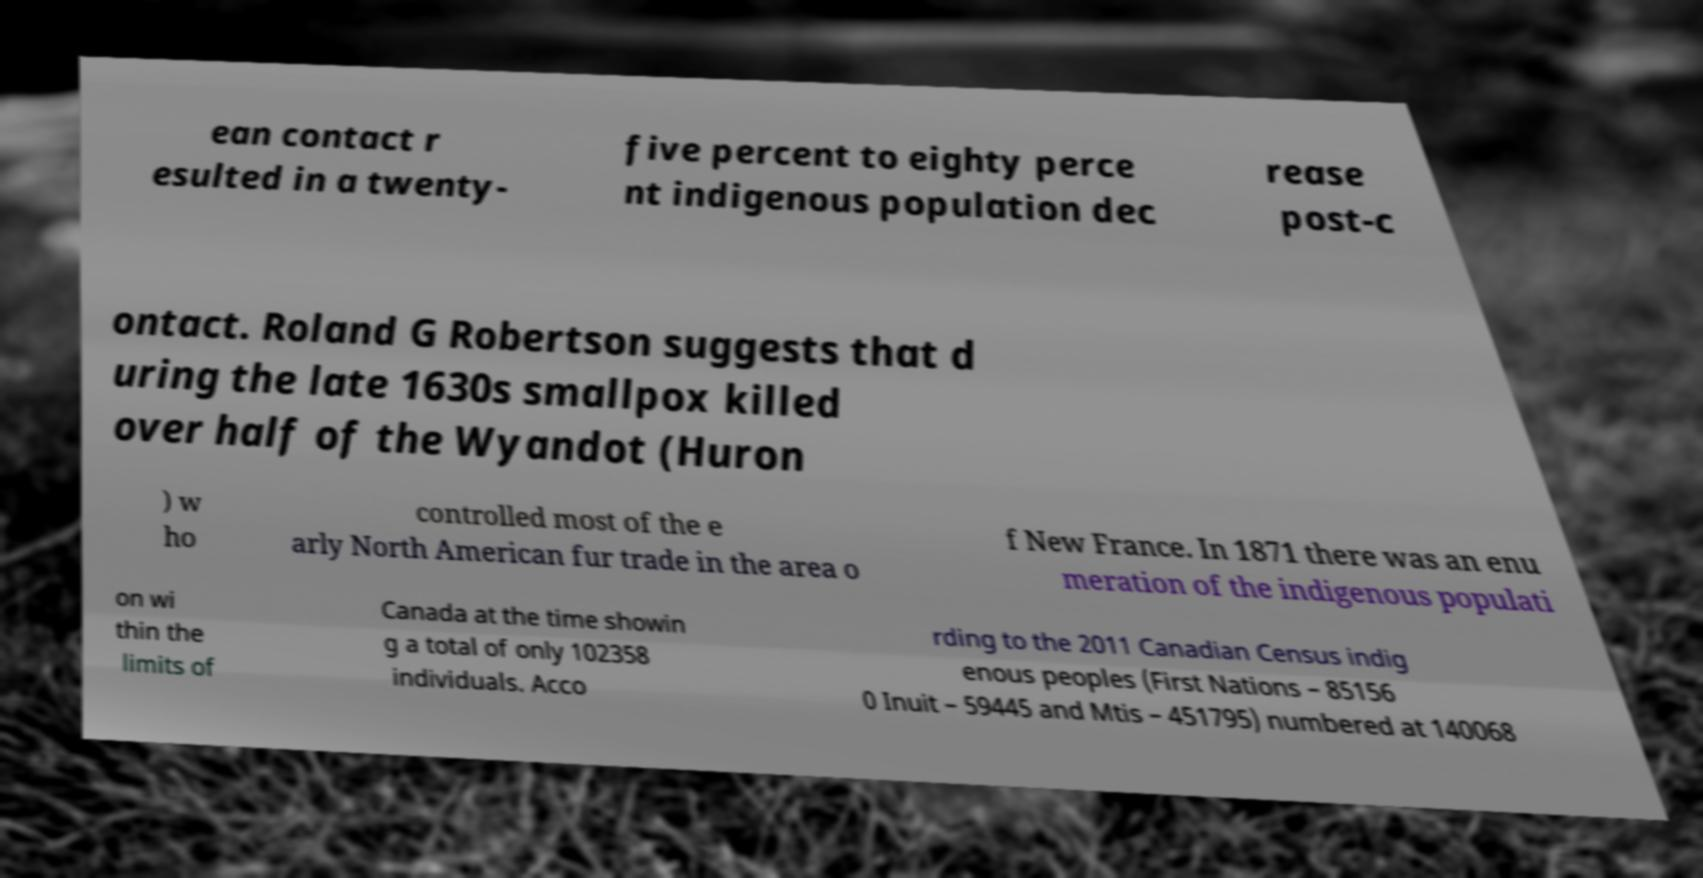Please read and relay the text visible in this image. What does it say? ean contact r esulted in a twenty- five percent to eighty perce nt indigenous population dec rease post-c ontact. Roland G Robertson suggests that d uring the late 1630s smallpox killed over half of the Wyandot (Huron ) w ho controlled most of the e arly North American fur trade in the area o f New France. In 1871 there was an enu meration of the indigenous populati on wi thin the limits of Canada at the time showin g a total of only 102358 individuals. Acco rding to the 2011 Canadian Census indig enous peoples (First Nations – 85156 0 Inuit – 59445 and Mtis – 451795) numbered at 140068 